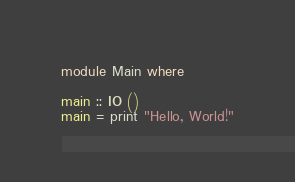Convert code to text. <code><loc_0><loc_0><loc_500><loc_500><_Haskell_>module Main where

main :: IO ()
main = print "Hello, World!"
</code> 